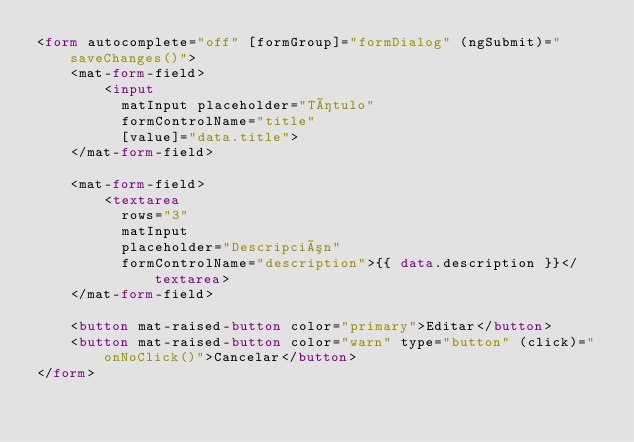<code> <loc_0><loc_0><loc_500><loc_500><_HTML_><form autocomplete="off" [formGroup]="formDialog" (ngSubmit)="saveChanges()">
    <mat-form-field>
        <input
          matInput placeholder="Título"
          formControlName="title"
          [value]="data.title">
    </mat-form-field>

    <mat-form-field>
        <textarea
          rows="3"
          matInput
          placeholder="Descripción"
          formControlName="description">{{ data.description }}</textarea>
    </mat-form-field>

    <button mat-raised-button color="primary">Editar</button>
    <button mat-raised-button color="warn" type="button" (click)="onNoClick()">Cancelar</button>
</form>
</code> 